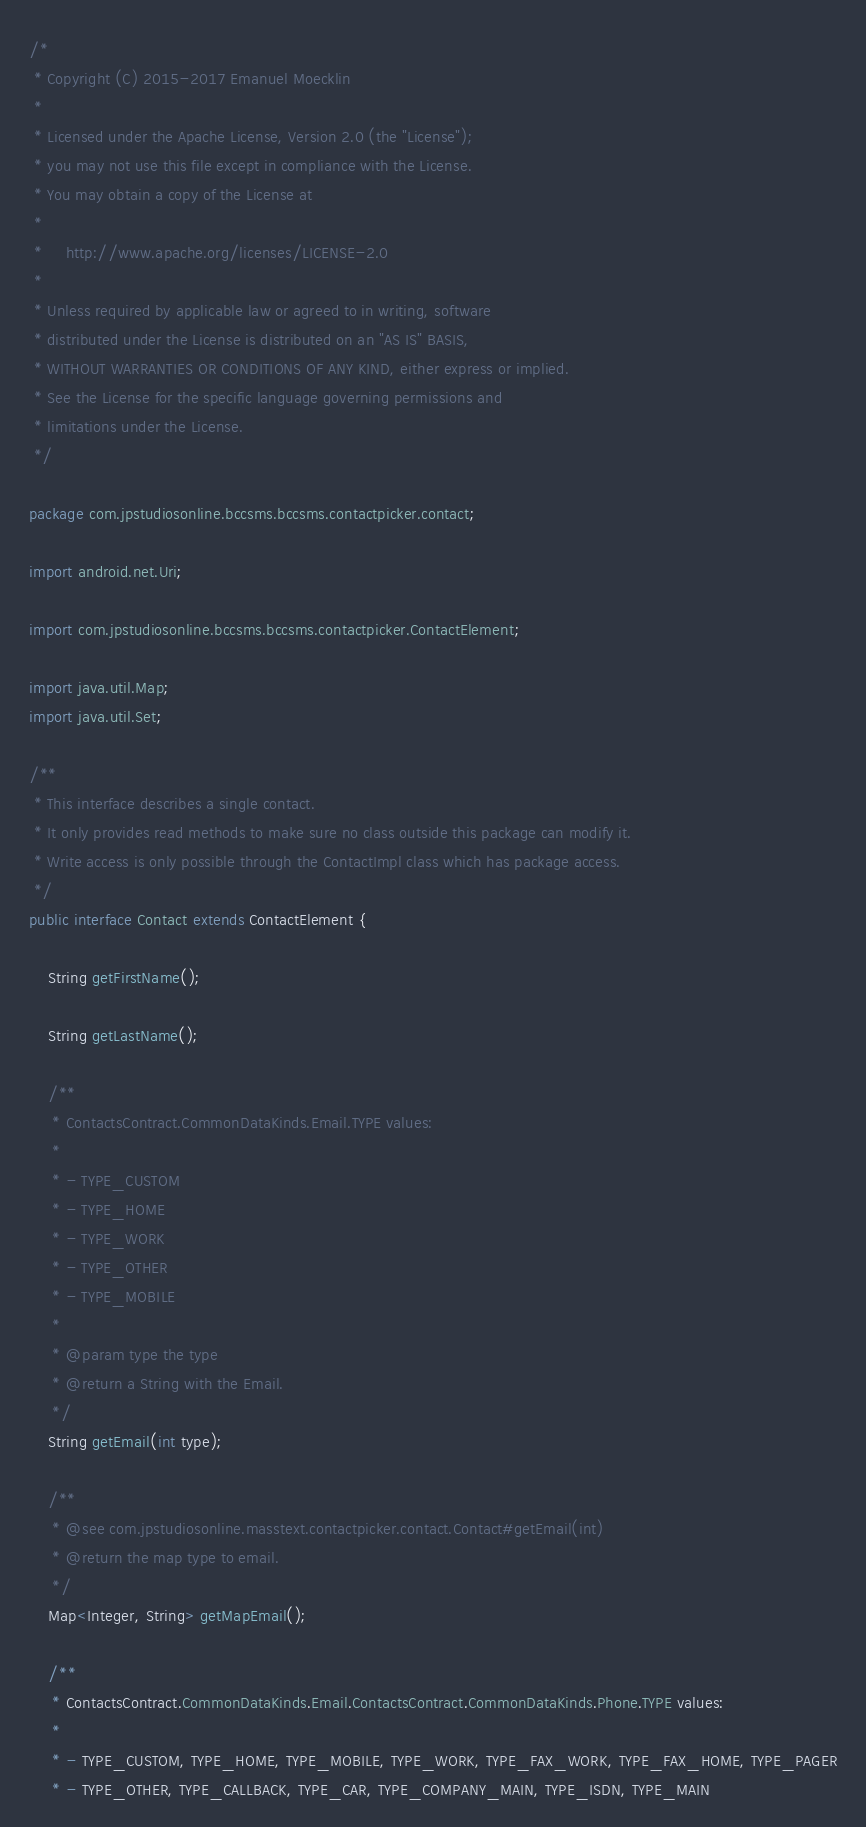<code> <loc_0><loc_0><loc_500><loc_500><_Java_>/*
 * Copyright (C) 2015-2017 Emanuel Moecklin
 *
 * Licensed under the Apache License, Version 2.0 (the "License");
 * you may not use this file except in compliance with the License.
 * You may obtain a copy of the License at
 *
 *     http://www.apache.org/licenses/LICENSE-2.0
 *
 * Unless required by applicable law or agreed to in writing, software
 * distributed under the License is distributed on an "AS IS" BASIS,
 * WITHOUT WARRANTIES OR CONDITIONS OF ANY KIND, either express or implied.
 * See the License for the specific language governing permissions and
 * limitations under the License.
 */

package com.jpstudiosonline.bccsms.bccsms.contactpicker.contact;

import android.net.Uri;

import com.jpstudiosonline.bccsms.bccsms.contactpicker.ContactElement;

import java.util.Map;
import java.util.Set;

/**
 * This interface describes a single contact.
 * It only provides read methods to make sure no class outside this package can modify it.
 * Write access is only possible through the ContactImpl class which has package access.
 */
public interface Contact extends ContactElement {

    String getFirstName();

    String getLastName();

    /**
     * ContactsContract.CommonDataKinds.Email.TYPE values:
     *
     * - TYPE_CUSTOM
     * - TYPE_HOME
     * - TYPE_WORK
     * - TYPE_OTHER
     * - TYPE_MOBILE
     *
     * @param type the type
     * @return a String with the Email.
     */
    String getEmail(int type);

    /**
     * @see com.jpstudiosonline.masstext.contactpicker.contact.Contact#getEmail(int)
     * @return the map type to email.
     */
    Map<Integer, String> getMapEmail();

    /**
     * ContactsContract.CommonDataKinds.Email.ContactsContract.CommonDataKinds.Phone.TYPE values:
     *
     * - TYPE_CUSTOM, TYPE_HOME, TYPE_MOBILE, TYPE_WORK, TYPE_FAX_WORK, TYPE_FAX_HOME, TYPE_PAGER
     * - TYPE_OTHER, TYPE_CALLBACK, TYPE_CAR, TYPE_COMPANY_MAIN, TYPE_ISDN, TYPE_MAIN</code> 